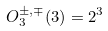Convert formula to latex. <formula><loc_0><loc_0><loc_500><loc_500>O _ { 3 } ^ { \pm , \mp } ( 3 ) = 2 ^ { 3 }</formula> 